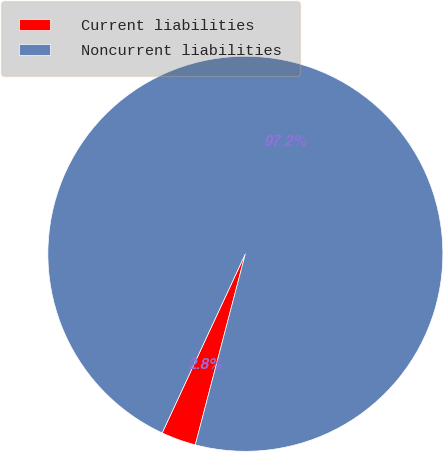Convert chart. <chart><loc_0><loc_0><loc_500><loc_500><pie_chart><fcel>Current liabilities<fcel>Noncurrent liabilities<nl><fcel>2.84%<fcel>97.16%<nl></chart> 